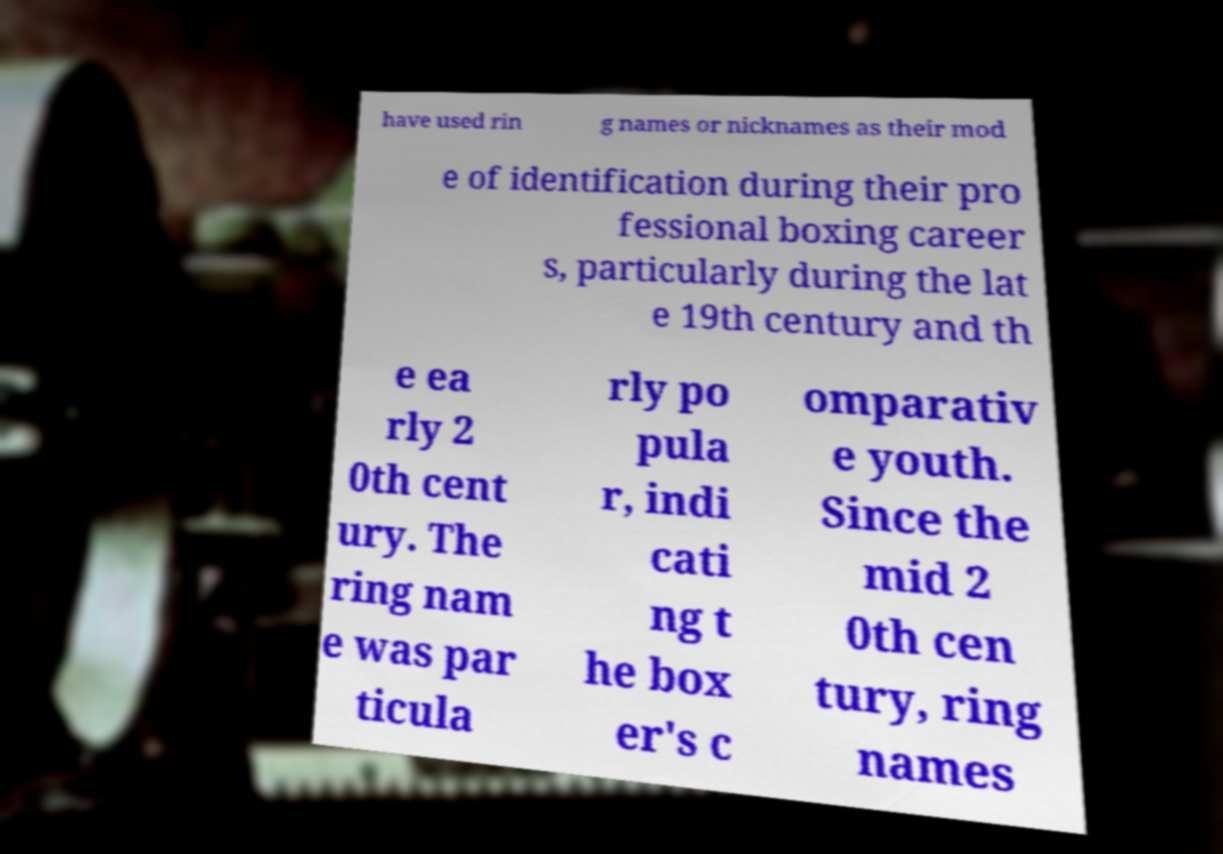Please identify and transcribe the text found in this image. have used rin g names or nicknames as their mod e of identification during their pro fessional boxing career s, particularly during the lat e 19th century and th e ea rly 2 0th cent ury. The ring nam e was par ticula rly po pula r, indi cati ng t he box er's c omparativ e youth. Since the mid 2 0th cen tury, ring names 